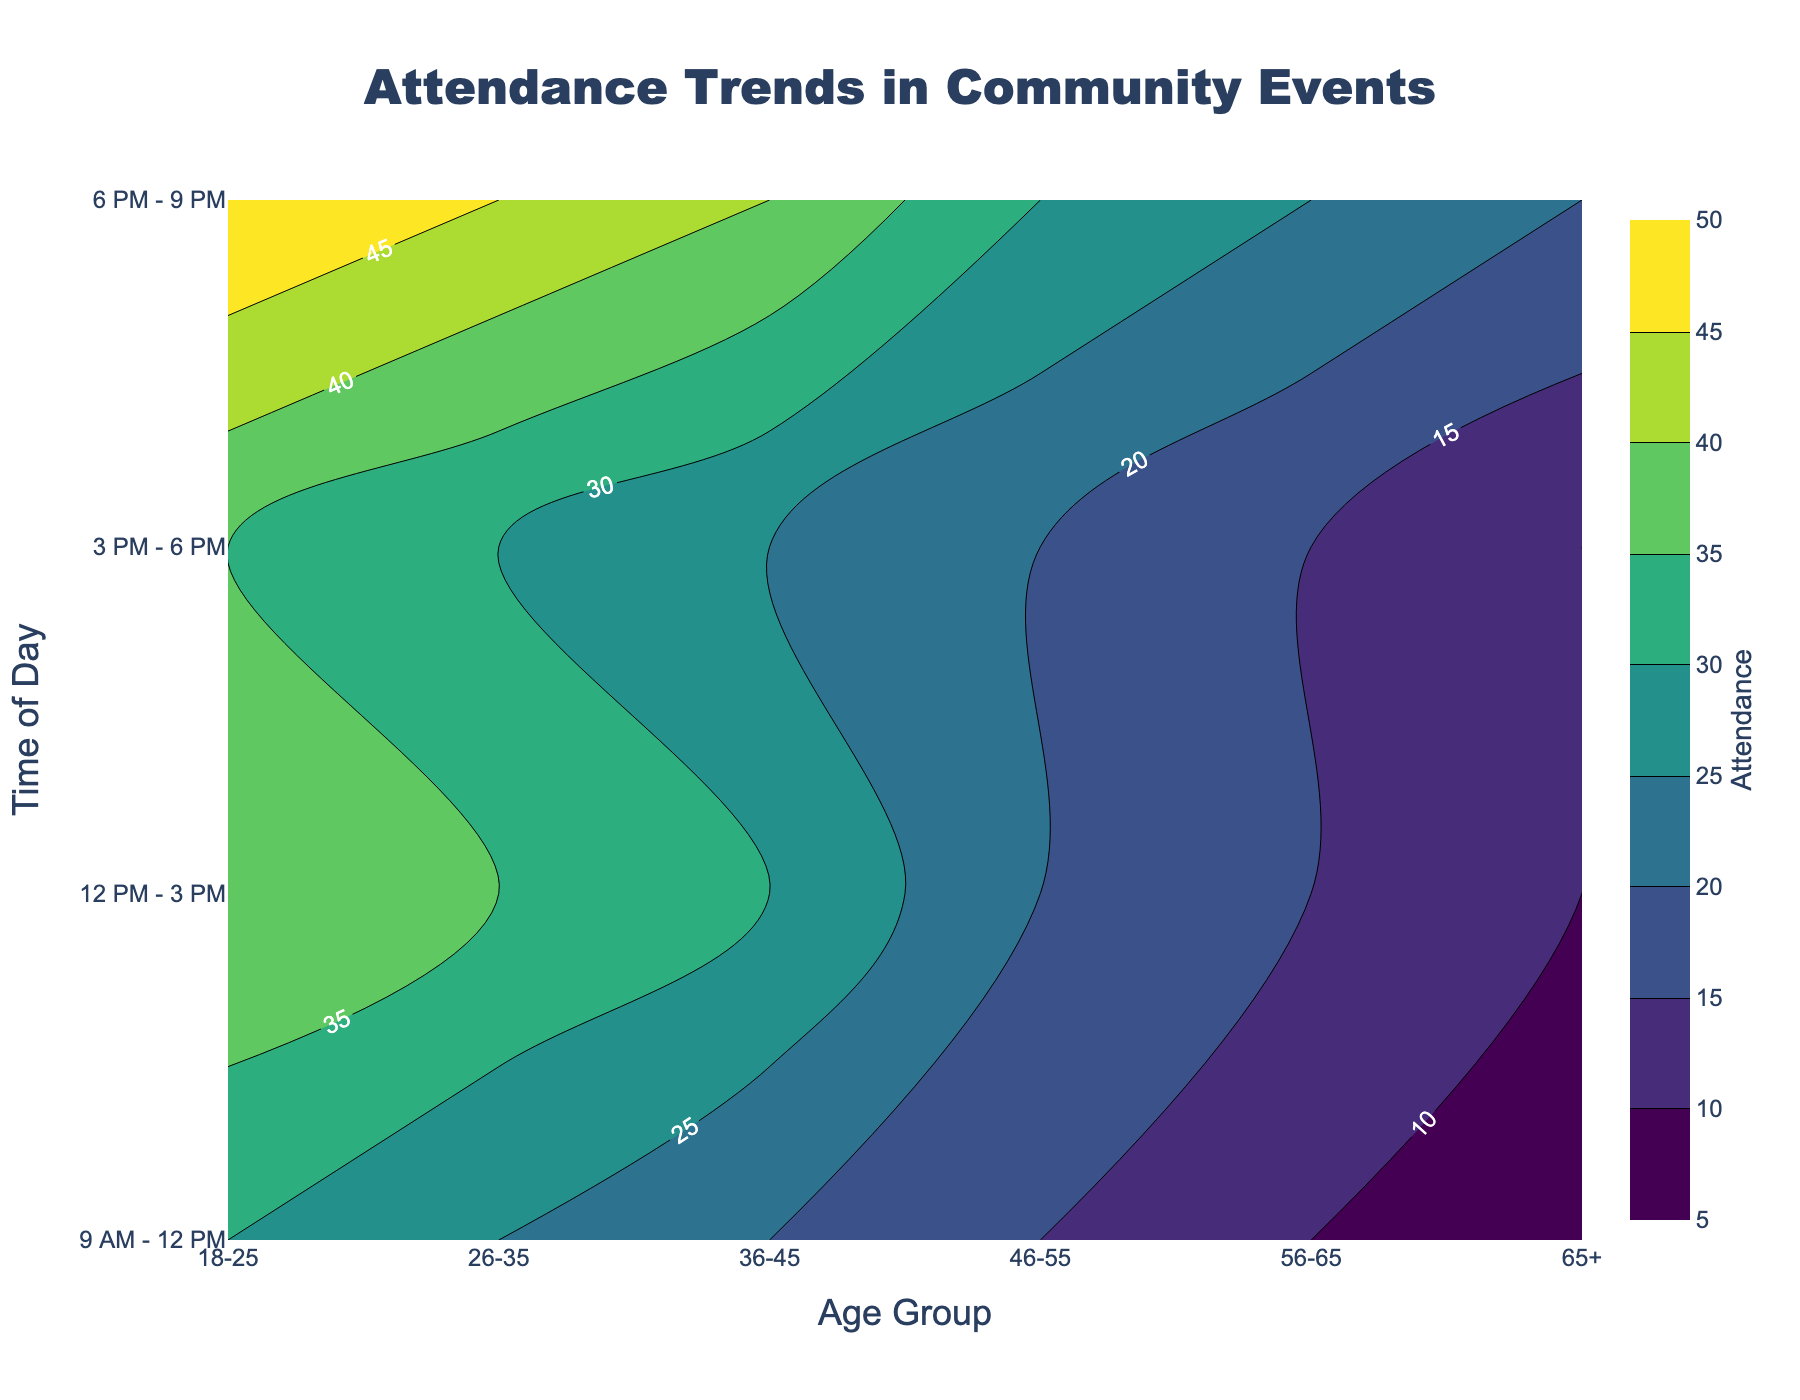What is the title of the figure? The title is usually displayed at the top of the figure. In this case, it can be identified by the distinct font and size, making it stand out compared to the rest of the text.
Answer: Attendance Trends in Community Events Which age group has the highest attendance during 6 PM - 9 PM? To find the highest attendance during the specified time, look at the "6 PM - 9 PM" row and compare the values across different age groups. The highest number in this row is the maximum attendance.
Answer: 18-25 What is the attendance trend for the age group 56-65 across different times of day? Observe the data points corresponding to the age group 56-65 in all rows (times of day). Note the attendance values in a sequence to understand the trend.
Answer: 10, 15, 15, 25 Which time of day has the lowest attendance for the age group 18-25? Look at the "18-25" column and compare attendance values from different rows representing times of day. The lowest number among these values indicates the time of day with the lowest attendance.
Answer: 9 AM - 12 PM What is the overall trend in attendance for the time slot 12 PM - 3 PM across all age groups? Check the attendance values in the "12 PM - 3 PM" row and analyze whether the numbers increase, decrease, or stay constant as the age group changes.
Answer: Decreasing trend Between the age groups 26-35 and 46-55, which one has higher attendance on average across all times of day? Calculate the average attendance for both age groups across all time slots by summing their attendance values and dividing by the number of time slots (4). Compare the results to determine the higher average.
Answer: 26-35 How does the attendance for the age group 36-45 during 3 PM - 6 PM compare to the attendance for the same age group during 9 AM - 12 PM? Compare the values at the intersection of the age group 36-45 with the respective time slots. The difference indicates if one is higher or lower than the other.
Answer: Higher Which time slot has the highest total attendance across all age groups? Summing up the attendance figures for each time slot (row) across all age groups and comparing the totals gives the highest total attendance time slot.
Answer: 6 PM - 9 PM What is the minimum attendance value shown in the figure, and which age group and time of day does it correspond to? Identify the smallest number in the entire contour plot and observe its corresponding age group (column) and time of day (row).
Answer: 5, 65+, 9 AM - 12 PM 